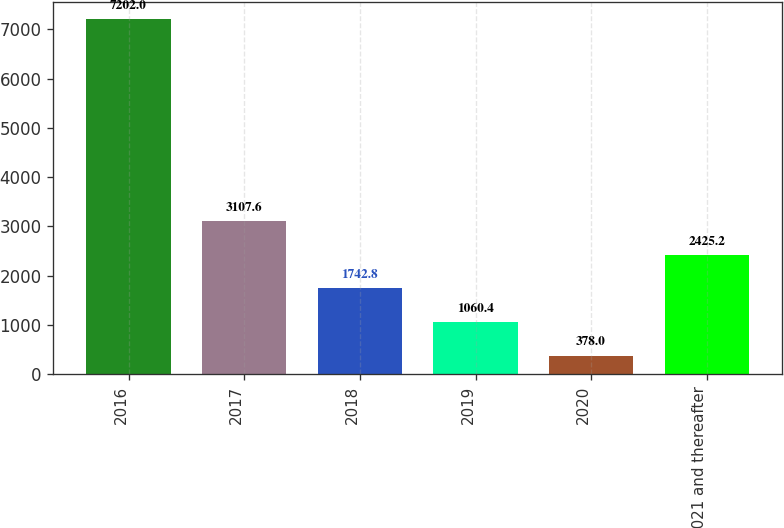Convert chart to OTSL. <chart><loc_0><loc_0><loc_500><loc_500><bar_chart><fcel>2016<fcel>2017<fcel>2018<fcel>2019<fcel>2020<fcel>2021 and thereafter<nl><fcel>7202<fcel>3107.6<fcel>1742.8<fcel>1060.4<fcel>378<fcel>2425.2<nl></chart> 